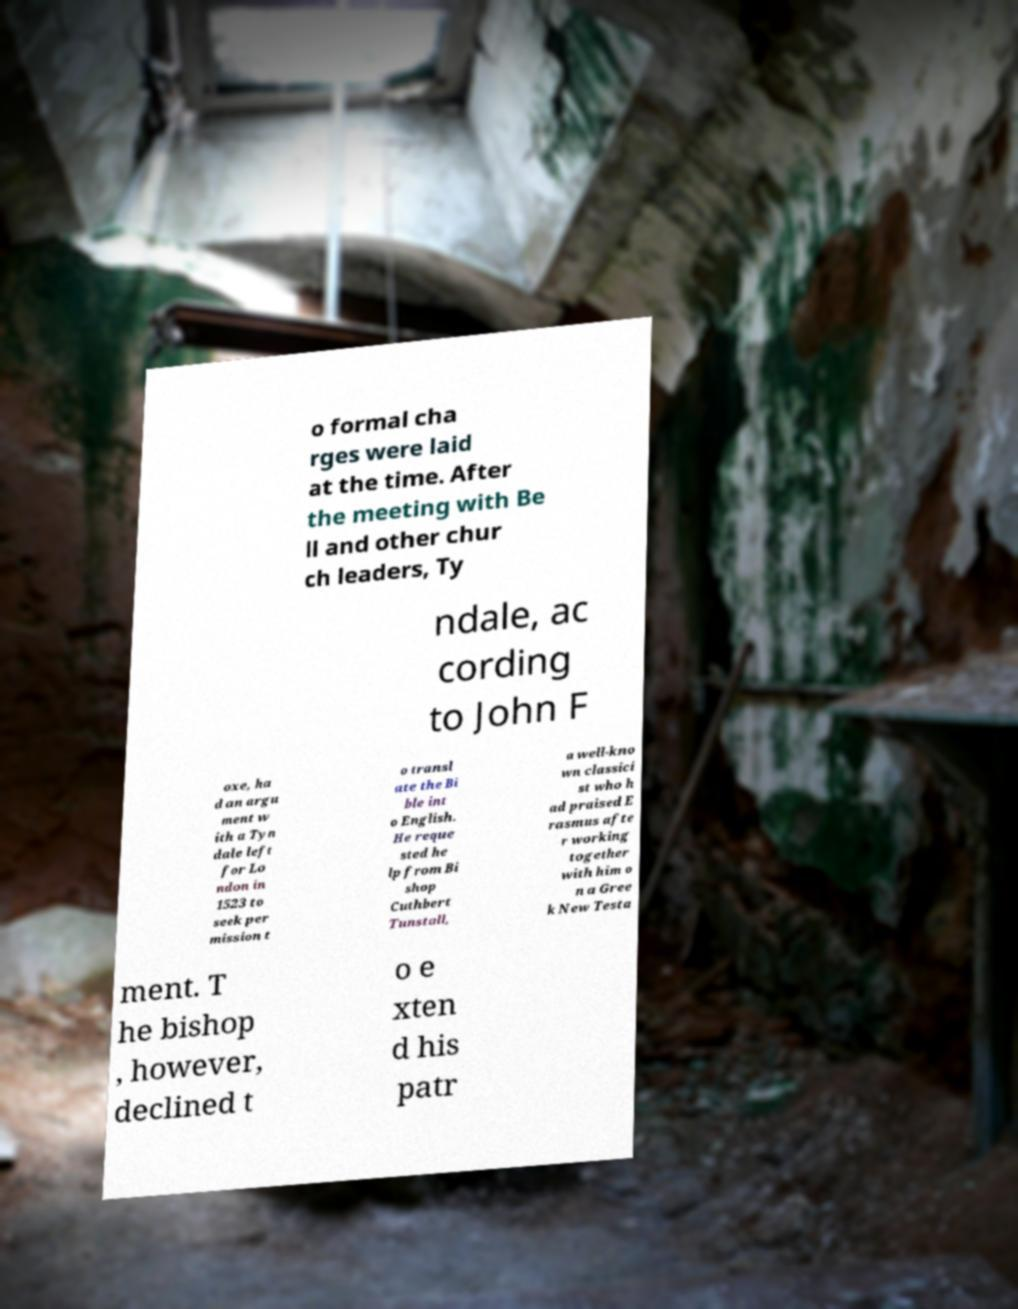Please identify and transcribe the text found in this image. o formal cha rges were laid at the time. After the meeting with Be ll and other chur ch leaders, Ty ndale, ac cording to John F oxe, ha d an argu ment w ith a Tyn dale left for Lo ndon in 1523 to seek per mission t o transl ate the Bi ble int o English. He reque sted he lp from Bi shop Cuthbert Tunstall, a well-kno wn classici st who h ad praised E rasmus afte r working together with him o n a Gree k New Testa ment. T he bishop , however, declined t o e xten d his patr 